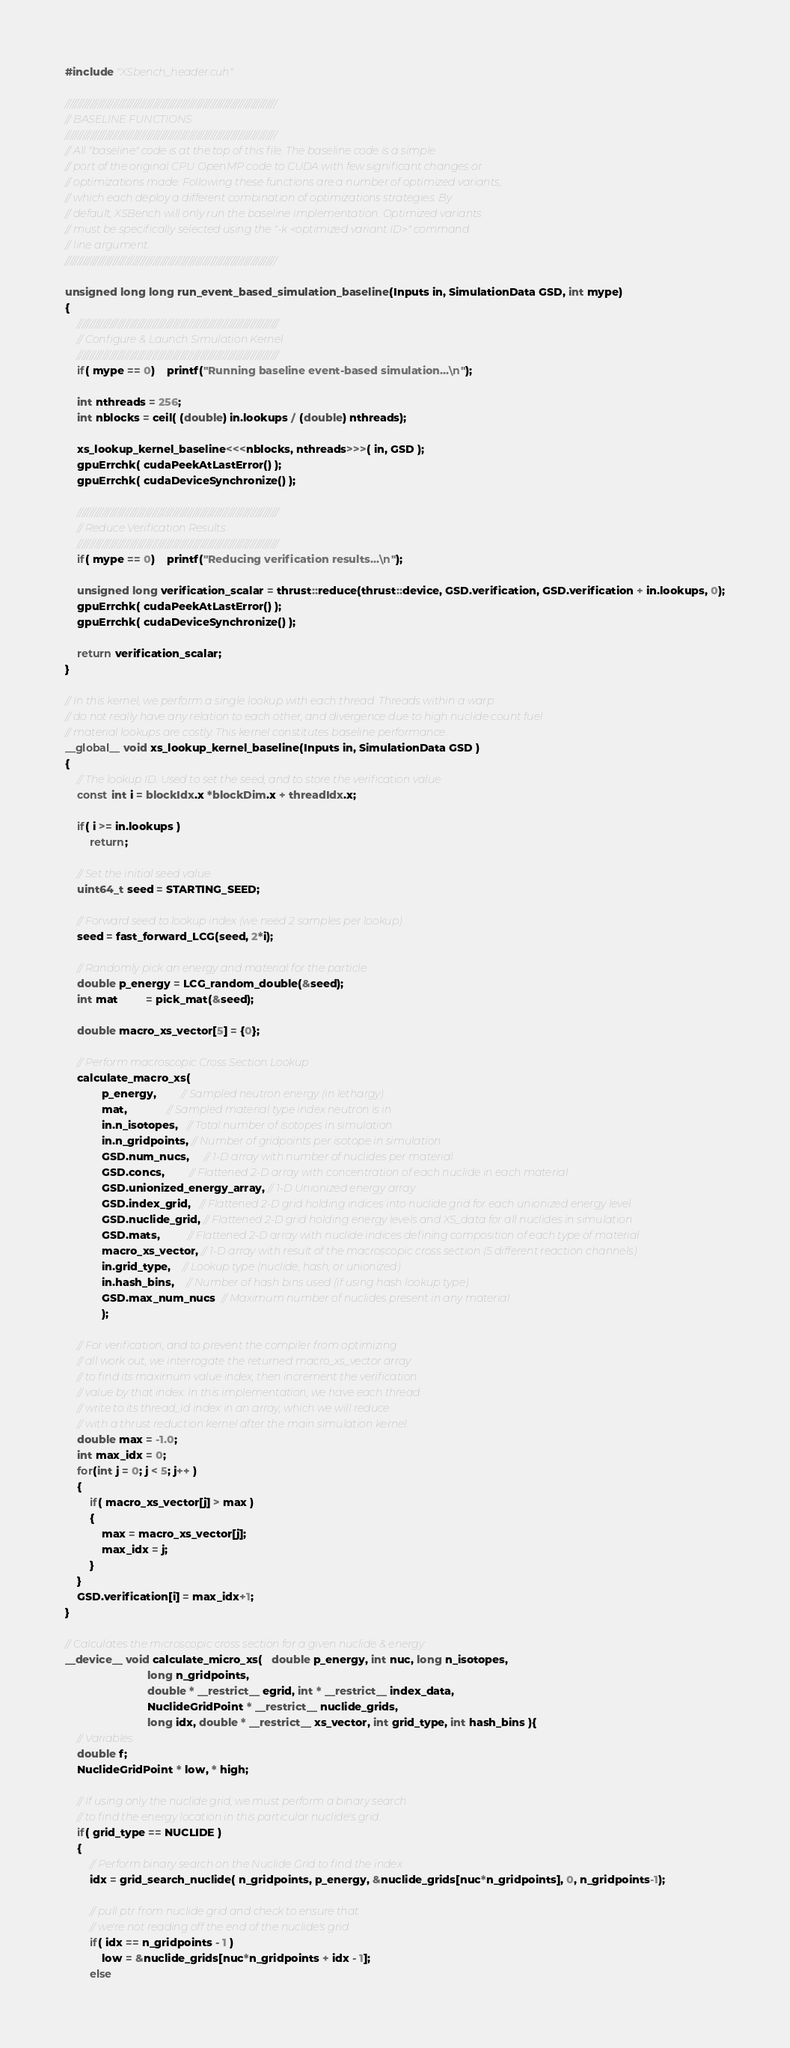Convert code to text. <code><loc_0><loc_0><loc_500><loc_500><_Cuda_>#include "XSbench_header.cuh"

////////////////////////////////////////////////////////////////////////////////////
// BASELINE FUNCTIONS
////////////////////////////////////////////////////////////////////////////////////
// All "baseline" code is at the top of this file. The baseline code is a simple
// port of the original CPU OpenMP code to CUDA with few significant changes or
// optimizations made. Following these functions are a number of optimized variants,
// which each deploy a different combination of optimizations strategies. By
// default, XSBench will only run the baseline implementation. Optimized variants
// must be specifically selected using the "-k <optimized variant ID>" command
// line argument.
////////////////////////////////////////////////////////////////////////////////////

unsigned long long run_event_based_simulation_baseline(Inputs in, SimulationData GSD, int mype)
{
	////////////////////////////////////////////////////////////////////////////////
	// Configure & Launch Simulation Kernel
	////////////////////////////////////////////////////////////////////////////////
	if( mype == 0)	printf("Running baseline event-based simulation...\n");

	int nthreads = 256;
	int nblocks = ceil( (double) in.lookups / (double) nthreads);

	xs_lookup_kernel_baseline<<<nblocks, nthreads>>>( in, GSD );
	gpuErrchk( cudaPeekAtLastError() );
	gpuErrchk( cudaDeviceSynchronize() );
	
	////////////////////////////////////////////////////////////////////////////////
	// Reduce Verification Results
	////////////////////////////////////////////////////////////////////////////////
	if( mype == 0)	printf("Reducing verification results...\n");

	unsigned long verification_scalar = thrust::reduce(thrust::device, GSD.verification, GSD.verification + in.lookups, 0);
	gpuErrchk( cudaPeekAtLastError() );
	gpuErrchk( cudaDeviceSynchronize() );

	return verification_scalar;
}

// In this kernel, we perform a single lookup with each thread. Threads within a warp
// do not really have any relation to each other, and divergence due to high nuclide count fuel
// material lookups are costly. This kernel constitutes baseline performance.
__global__ void xs_lookup_kernel_baseline(Inputs in, SimulationData GSD )
{
	// The lookup ID. Used to set the seed, and to store the verification value
	const int i = blockIdx.x *blockDim.x + threadIdx.x;

	if( i >= in.lookups )
		return;

	// Set the initial seed value
	uint64_t seed = STARTING_SEED;	

	// Forward seed to lookup index (we need 2 samples per lookup)
	seed = fast_forward_LCG(seed, 2*i);

	// Randomly pick an energy and material for the particle
	double p_energy = LCG_random_double(&seed);
	int mat         = pick_mat(&seed); 
		
	double macro_xs_vector[5] = {0};
		
	// Perform macroscopic Cross Section Lookup
	calculate_macro_xs(
			p_energy,        // Sampled neutron energy (in lethargy)
			mat,             // Sampled material type index neutron is in
			in.n_isotopes,   // Total number of isotopes in simulation
			in.n_gridpoints, // Number of gridpoints per isotope in simulation
			GSD.num_nucs,     // 1-D array with number of nuclides per material
			GSD.concs,        // Flattened 2-D array with concentration of each nuclide in each material
			GSD.unionized_energy_array, // 1-D Unionized energy array
			GSD.index_grid,   // Flattened 2-D grid holding indices into nuclide grid for each unionized energy level
			GSD.nuclide_grid, // Flattened 2-D grid holding energy levels and XS_data for all nuclides in simulation
			GSD.mats,         // Flattened 2-D array with nuclide indices defining composition of each type of material
			macro_xs_vector, // 1-D array with result of the macroscopic cross section (5 different reaction channels)
			in.grid_type,    // Lookup type (nuclide, hash, or unionized)
			in.hash_bins,    // Number of hash bins used (if using hash lookup type)
			GSD.max_num_nucs  // Maximum number of nuclides present in any material
			);

	// For verification, and to prevent the compiler from optimizing
	// all work out, we interrogate the returned macro_xs_vector array
	// to find its maximum value index, then increment the verification
	// value by that index. In this implementation, we have each thread
	// write to its thread_id index in an array, which we will reduce
	// with a thrust reduction kernel after the main simulation kernel.
	double max = -1.0;
	int max_idx = 0;
	for(int j = 0; j < 5; j++ )
	{
		if( macro_xs_vector[j] > max )
		{
			max = macro_xs_vector[j];
			max_idx = j;
		}
	}
	GSD.verification[i] = max_idx+1;
}

// Calculates the microscopic cross section for a given nuclide & energy
__device__ void calculate_micro_xs(   double p_energy, int nuc, long n_isotopes,
                           long n_gridpoints,
                           double * __restrict__ egrid, int * __restrict__ index_data,
                           NuclideGridPoint * __restrict__ nuclide_grids,
                           long idx, double * __restrict__ xs_vector, int grid_type, int hash_bins ){
	// Variables
	double f;
	NuclideGridPoint * low, * high;

	// If using only the nuclide grid, we must perform a binary search
	// to find the energy location in this particular nuclide's grid.
	if( grid_type == NUCLIDE )
	{
		// Perform binary search on the Nuclide Grid to find the index
		idx = grid_search_nuclide( n_gridpoints, p_energy, &nuclide_grids[nuc*n_gridpoints], 0, n_gridpoints-1);

		// pull ptr from nuclide grid and check to ensure that
		// we're not reading off the end of the nuclide's grid
		if( idx == n_gridpoints - 1 )
			low = &nuclide_grids[nuc*n_gridpoints + idx - 1];
		else</code> 